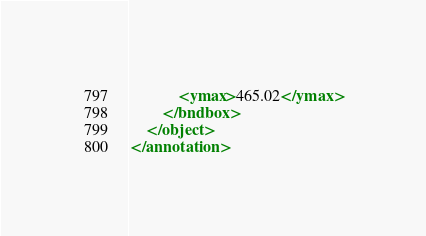Convert code to text. <code><loc_0><loc_0><loc_500><loc_500><_XML_>            <ymax>465.02</ymax>
        </bndbox>
    </object>
</annotation>
</code> 